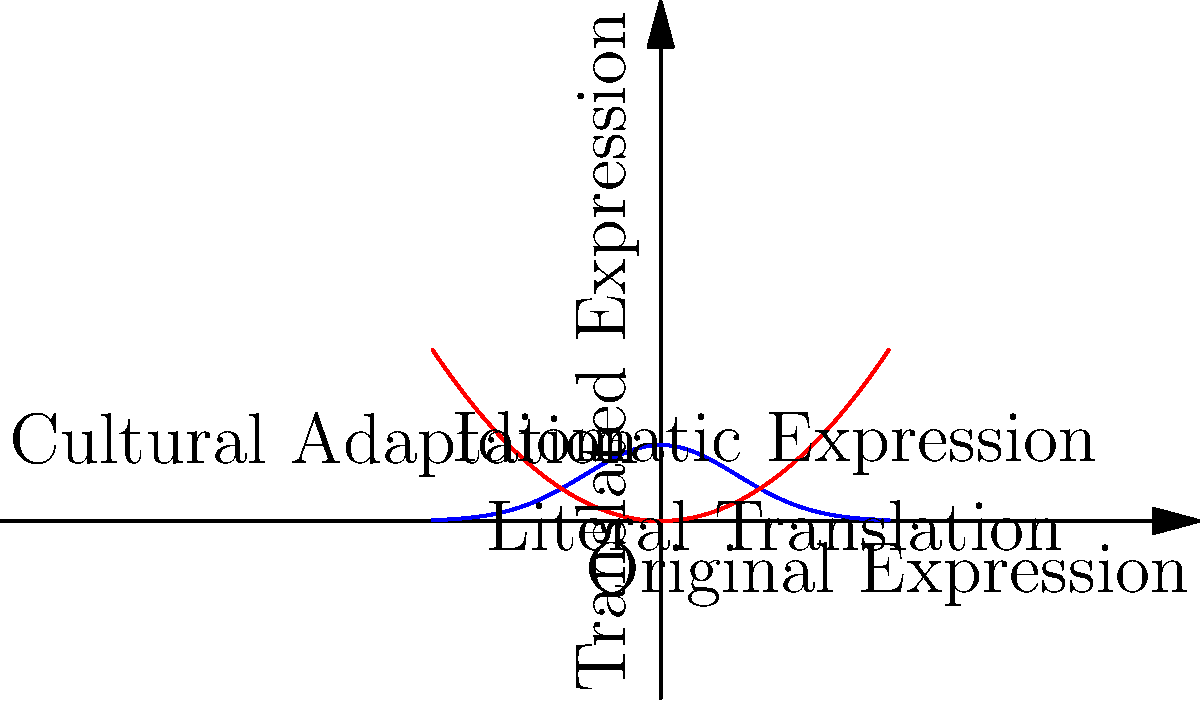In translating idiomatic expressions from Slavic languages to English, consider the graph above where the blue curve represents the original meaning and the red curve represents a literal translation. At which point does the translation process require the most cultural adaptation to preserve the original meaning? To answer this question, we need to analyze the graph and understand the translation process:

1. The blue curve represents the original idiomatic expression in the Slavic language.
2. The red curve represents a literal, word-for-word translation into English.
3. The vertical distance between the two curves represents the degree of cultural adaptation needed.

Step 1: Observe the graph and identify where the two curves are furthest apart vertically.
Step 2: Notice that the maximum vertical distance occurs at x = 0.
Step 3: At x = 0, the blue curve (original expression) is at its peak, while the red curve (literal translation) is at its minimum.
Step 4: This point represents where the literal translation diverges most from the original meaning, requiring the most cultural adaptation.
Step 5: The label "Cultural Adaptation" is placed at (0, f(0)), confirming this is the correct point.

Therefore, the point where the translation process requires the most cultural adaptation to preserve the original meaning is at x = 0, where the vertical distance between the curves is greatest.
Answer: x = 0 